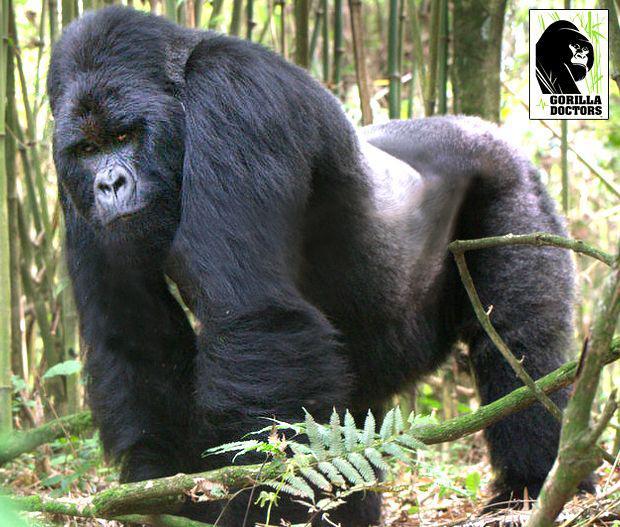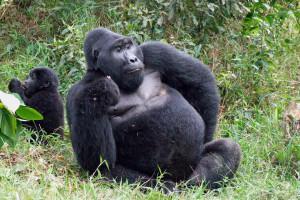The first image is the image on the left, the second image is the image on the right. Evaluate the accuracy of this statement regarding the images: "The righthand image contains no more than two gorillas, including one with a big round belly.". Is it true? Answer yes or no. Yes. The first image is the image on the left, the second image is the image on the right. For the images shown, is this caption "The right image contains no more than two gorillas." true? Answer yes or no. Yes. 